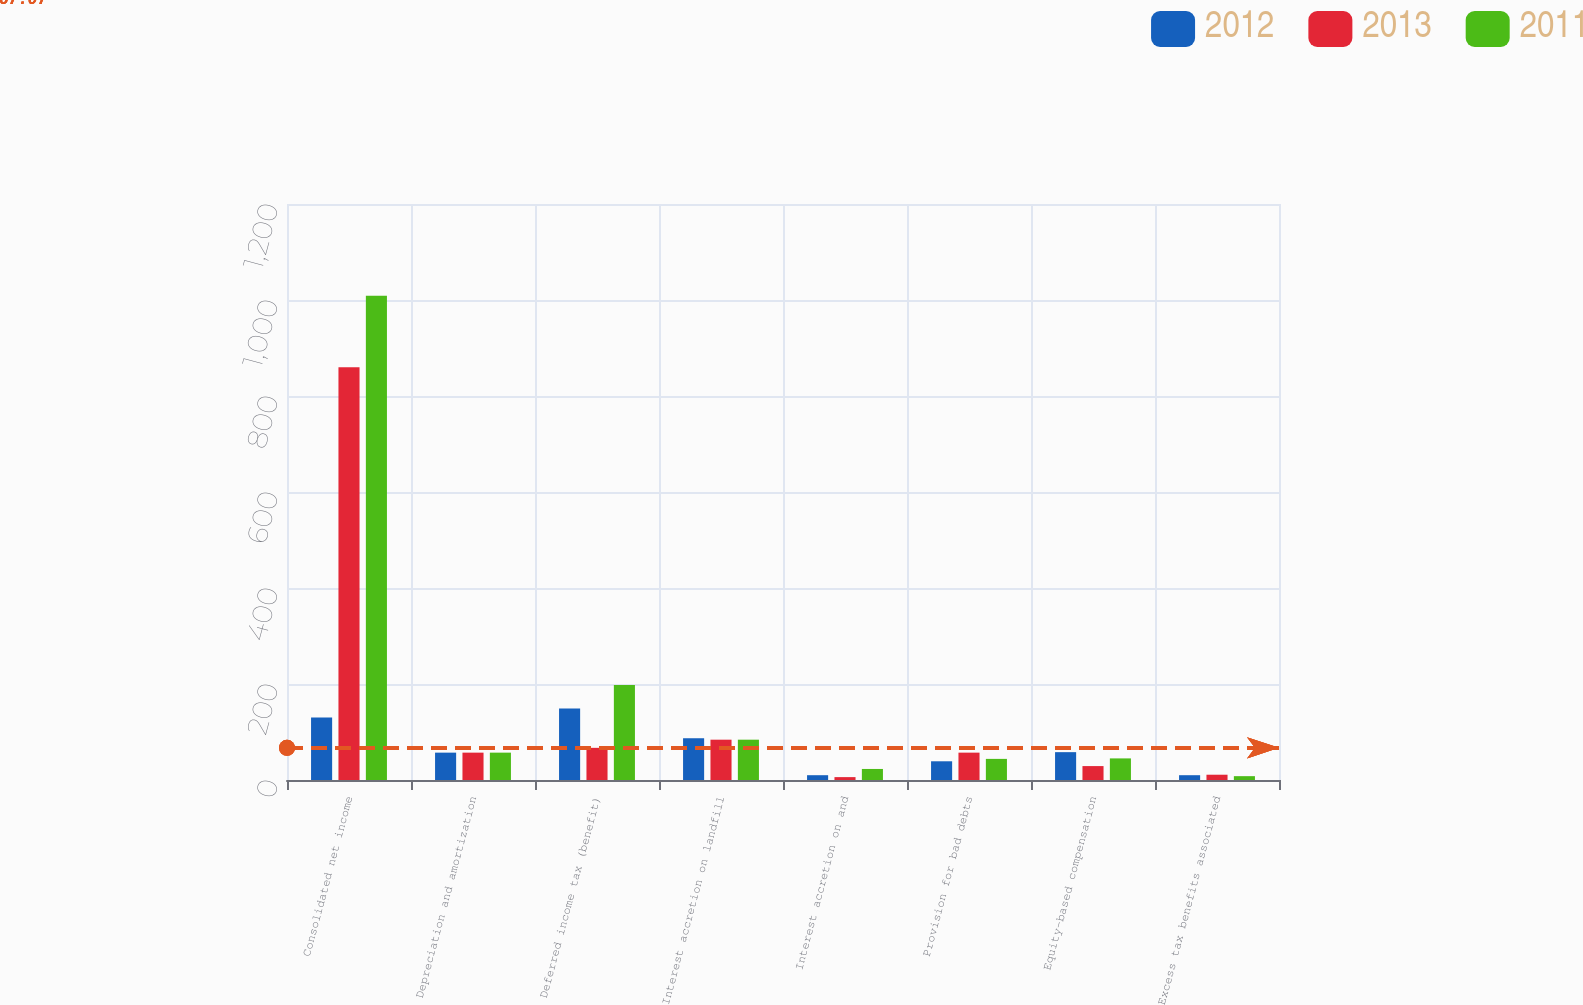Convert chart. <chart><loc_0><loc_0><loc_500><loc_500><stacked_bar_chart><ecel><fcel>Consolidated net income<fcel>Depreciation and amortization<fcel>Deferred income tax (benefit)<fcel>Interest accretion on landfill<fcel>Interest accretion on and<fcel>Provision for bad debts<fcel>Equity-based compensation<fcel>Excess tax benefits associated<nl><fcel>2012<fcel>130<fcel>57<fcel>149<fcel>87<fcel>10<fcel>39<fcel>58<fcel>10<nl><fcel>2013<fcel>860<fcel>57<fcel>67<fcel>84<fcel>6<fcel>57<fcel>29<fcel>11<nl><fcel>2011<fcel>1009<fcel>57<fcel>198<fcel>84<fcel>23<fcel>44<fcel>45<fcel>8<nl></chart> 